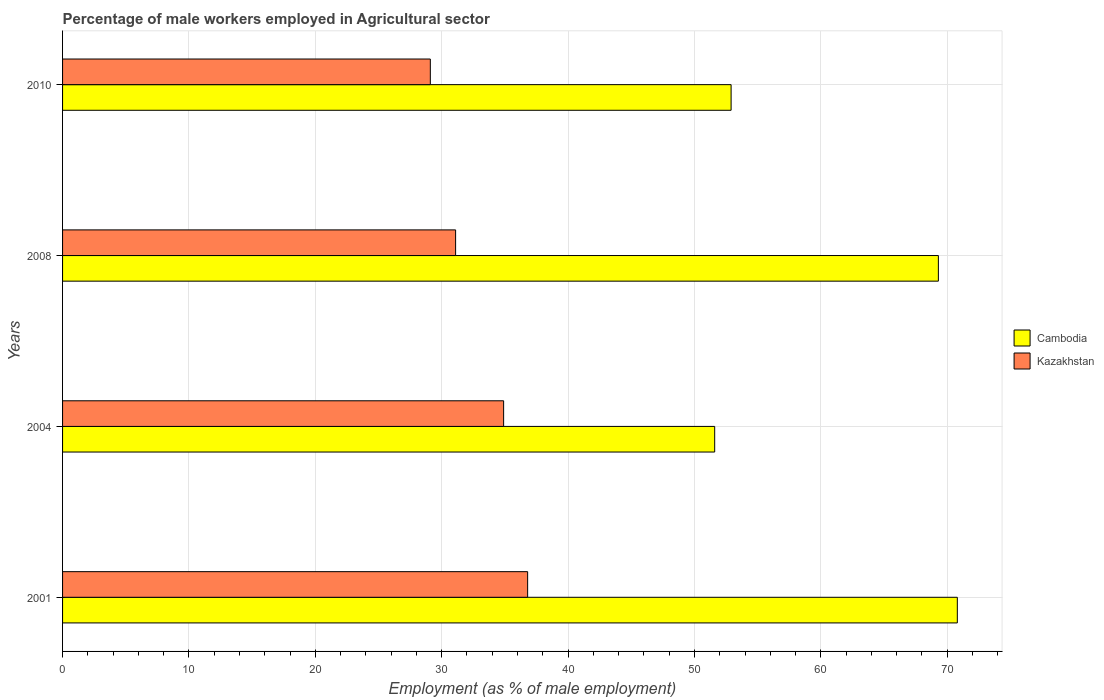How many groups of bars are there?
Provide a succinct answer. 4. How many bars are there on the 2nd tick from the top?
Keep it short and to the point. 2. What is the percentage of male workers employed in Agricultural sector in Cambodia in 2004?
Offer a very short reply. 51.6. Across all years, what is the maximum percentage of male workers employed in Agricultural sector in Cambodia?
Your answer should be compact. 70.8. Across all years, what is the minimum percentage of male workers employed in Agricultural sector in Kazakhstan?
Your response must be concise. 29.1. In which year was the percentage of male workers employed in Agricultural sector in Cambodia maximum?
Offer a very short reply. 2001. In which year was the percentage of male workers employed in Agricultural sector in Kazakhstan minimum?
Provide a short and direct response. 2010. What is the total percentage of male workers employed in Agricultural sector in Cambodia in the graph?
Provide a succinct answer. 244.6. What is the difference between the percentage of male workers employed in Agricultural sector in Cambodia in 2004 and that in 2008?
Make the answer very short. -17.7. What is the difference between the percentage of male workers employed in Agricultural sector in Kazakhstan in 2010 and the percentage of male workers employed in Agricultural sector in Cambodia in 2008?
Ensure brevity in your answer.  -40.2. What is the average percentage of male workers employed in Agricultural sector in Kazakhstan per year?
Ensure brevity in your answer.  32.98. In the year 2004, what is the difference between the percentage of male workers employed in Agricultural sector in Cambodia and percentage of male workers employed in Agricultural sector in Kazakhstan?
Provide a succinct answer. 16.7. In how many years, is the percentage of male workers employed in Agricultural sector in Cambodia greater than 22 %?
Provide a short and direct response. 4. What is the ratio of the percentage of male workers employed in Agricultural sector in Cambodia in 2001 to that in 2004?
Your answer should be compact. 1.37. Is the percentage of male workers employed in Agricultural sector in Cambodia in 2001 less than that in 2008?
Make the answer very short. No. What is the difference between the highest and the second highest percentage of male workers employed in Agricultural sector in Cambodia?
Your answer should be compact. 1.5. What is the difference between the highest and the lowest percentage of male workers employed in Agricultural sector in Kazakhstan?
Ensure brevity in your answer.  7.7. Is the sum of the percentage of male workers employed in Agricultural sector in Cambodia in 2001 and 2004 greater than the maximum percentage of male workers employed in Agricultural sector in Kazakhstan across all years?
Ensure brevity in your answer.  Yes. What does the 1st bar from the top in 2001 represents?
Keep it short and to the point. Kazakhstan. What does the 2nd bar from the bottom in 2001 represents?
Make the answer very short. Kazakhstan. How many years are there in the graph?
Give a very brief answer. 4. Does the graph contain grids?
Your answer should be very brief. Yes. Where does the legend appear in the graph?
Ensure brevity in your answer.  Center right. How many legend labels are there?
Offer a very short reply. 2. What is the title of the graph?
Provide a succinct answer. Percentage of male workers employed in Agricultural sector. What is the label or title of the X-axis?
Offer a terse response. Employment (as % of male employment). What is the Employment (as % of male employment) of Cambodia in 2001?
Offer a very short reply. 70.8. What is the Employment (as % of male employment) of Kazakhstan in 2001?
Your answer should be compact. 36.8. What is the Employment (as % of male employment) of Cambodia in 2004?
Offer a very short reply. 51.6. What is the Employment (as % of male employment) of Kazakhstan in 2004?
Provide a short and direct response. 34.9. What is the Employment (as % of male employment) in Cambodia in 2008?
Your answer should be very brief. 69.3. What is the Employment (as % of male employment) of Kazakhstan in 2008?
Give a very brief answer. 31.1. What is the Employment (as % of male employment) in Cambodia in 2010?
Make the answer very short. 52.9. What is the Employment (as % of male employment) in Kazakhstan in 2010?
Ensure brevity in your answer.  29.1. Across all years, what is the maximum Employment (as % of male employment) of Cambodia?
Provide a short and direct response. 70.8. Across all years, what is the maximum Employment (as % of male employment) of Kazakhstan?
Your response must be concise. 36.8. Across all years, what is the minimum Employment (as % of male employment) in Cambodia?
Offer a very short reply. 51.6. Across all years, what is the minimum Employment (as % of male employment) of Kazakhstan?
Provide a succinct answer. 29.1. What is the total Employment (as % of male employment) in Cambodia in the graph?
Offer a terse response. 244.6. What is the total Employment (as % of male employment) in Kazakhstan in the graph?
Your answer should be compact. 131.9. What is the difference between the Employment (as % of male employment) of Kazakhstan in 2001 and that in 2004?
Provide a short and direct response. 1.9. What is the difference between the Employment (as % of male employment) in Cambodia in 2001 and that in 2008?
Give a very brief answer. 1.5. What is the difference between the Employment (as % of male employment) of Cambodia in 2004 and that in 2008?
Give a very brief answer. -17.7. What is the difference between the Employment (as % of male employment) of Cambodia in 2008 and that in 2010?
Provide a short and direct response. 16.4. What is the difference between the Employment (as % of male employment) in Kazakhstan in 2008 and that in 2010?
Provide a short and direct response. 2. What is the difference between the Employment (as % of male employment) in Cambodia in 2001 and the Employment (as % of male employment) in Kazakhstan in 2004?
Give a very brief answer. 35.9. What is the difference between the Employment (as % of male employment) in Cambodia in 2001 and the Employment (as % of male employment) in Kazakhstan in 2008?
Your answer should be very brief. 39.7. What is the difference between the Employment (as % of male employment) in Cambodia in 2001 and the Employment (as % of male employment) in Kazakhstan in 2010?
Your answer should be very brief. 41.7. What is the difference between the Employment (as % of male employment) in Cambodia in 2008 and the Employment (as % of male employment) in Kazakhstan in 2010?
Provide a short and direct response. 40.2. What is the average Employment (as % of male employment) of Cambodia per year?
Provide a short and direct response. 61.15. What is the average Employment (as % of male employment) in Kazakhstan per year?
Offer a very short reply. 32.98. In the year 2001, what is the difference between the Employment (as % of male employment) of Cambodia and Employment (as % of male employment) of Kazakhstan?
Offer a very short reply. 34. In the year 2008, what is the difference between the Employment (as % of male employment) of Cambodia and Employment (as % of male employment) of Kazakhstan?
Ensure brevity in your answer.  38.2. In the year 2010, what is the difference between the Employment (as % of male employment) in Cambodia and Employment (as % of male employment) in Kazakhstan?
Your answer should be very brief. 23.8. What is the ratio of the Employment (as % of male employment) of Cambodia in 2001 to that in 2004?
Make the answer very short. 1.37. What is the ratio of the Employment (as % of male employment) in Kazakhstan in 2001 to that in 2004?
Provide a succinct answer. 1.05. What is the ratio of the Employment (as % of male employment) of Cambodia in 2001 to that in 2008?
Make the answer very short. 1.02. What is the ratio of the Employment (as % of male employment) of Kazakhstan in 2001 to that in 2008?
Ensure brevity in your answer.  1.18. What is the ratio of the Employment (as % of male employment) of Cambodia in 2001 to that in 2010?
Provide a succinct answer. 1.34. What is the ratio of the Employment (as % of male employment) of Kazakhstan in 2001 to that in 2010?
Your answer should be compact. 1.26. What is the ratio of the Employment (as % of male employment) in Cambodia in 2004 to that in 2008?
Your response must be concise. 0.74. What is the ratio of the Employment (as % of male employment) of Kazakhstan in 2004 to that in 2008?
Your answer should be very brief. 1.12. What is the ratio of the Employment (as % of male employment) in Cambodia in 2004 to that in 2010?
Your response must be concise. 0.98. What is the ratio of the Employment (as % of male employment) of Kazakhstan in 2004 to that in 2010?
Your response must be concise. 1.2. What is the ratio of the Employment (as % of male employment) in Cambodia in 2008 to that in 2010?
Offer a terse response. 1.31. What is the ratio of the Employment (as % of male employment) in Kazakhstan in 2008 to that in 2010?
Offer a very short reply. 1.07. 